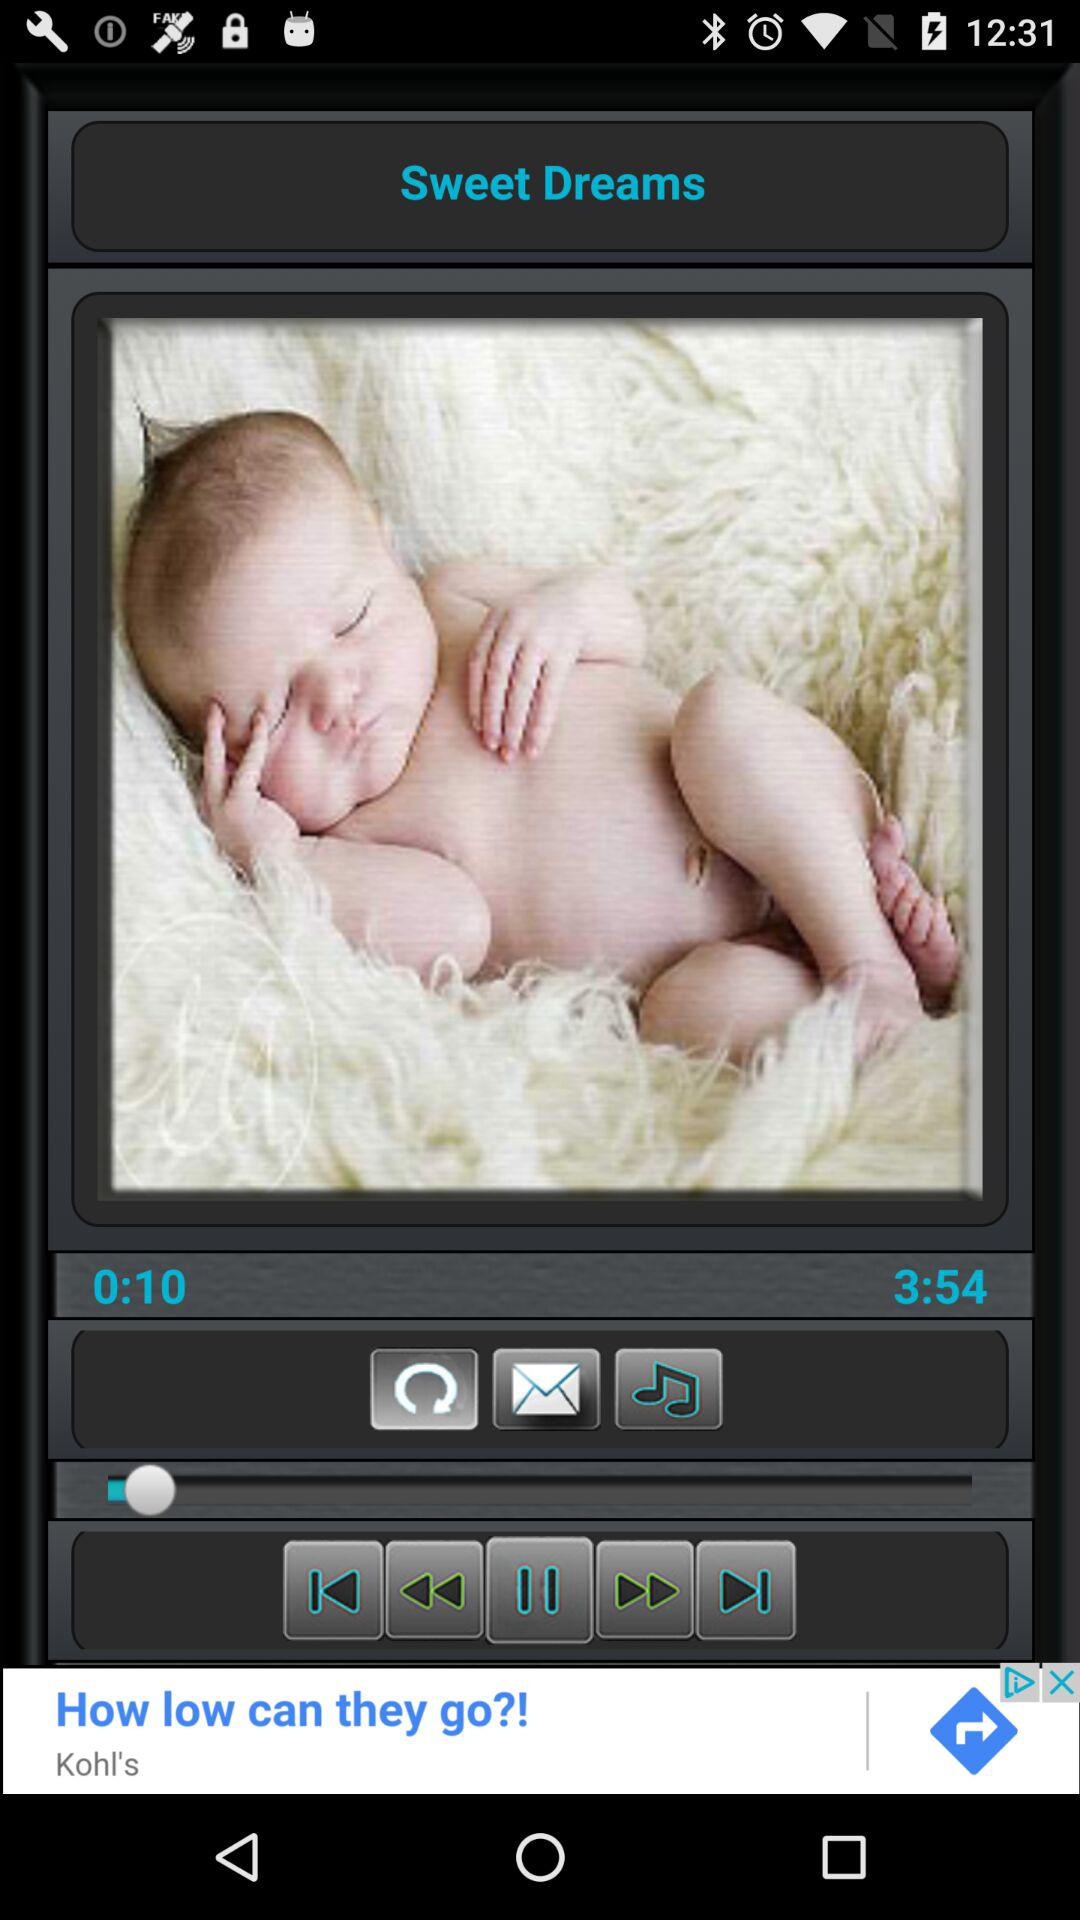What is the song name? The song name is "Sweet Dreams". 